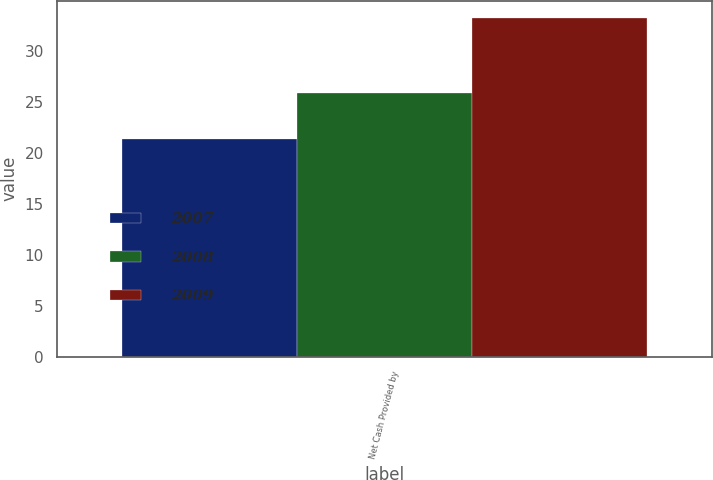Convert chart. <chart><loc_0><loc_0><loc_500><loc_500><stacked_bar_chart><ecel><fcel>Net Cash Provided by<nl><fcel>2007<fcel>21.4<nl><fcel>2008<fcel>25.9<nl><fcel>2009<fcel>33.3<nl></chart> 